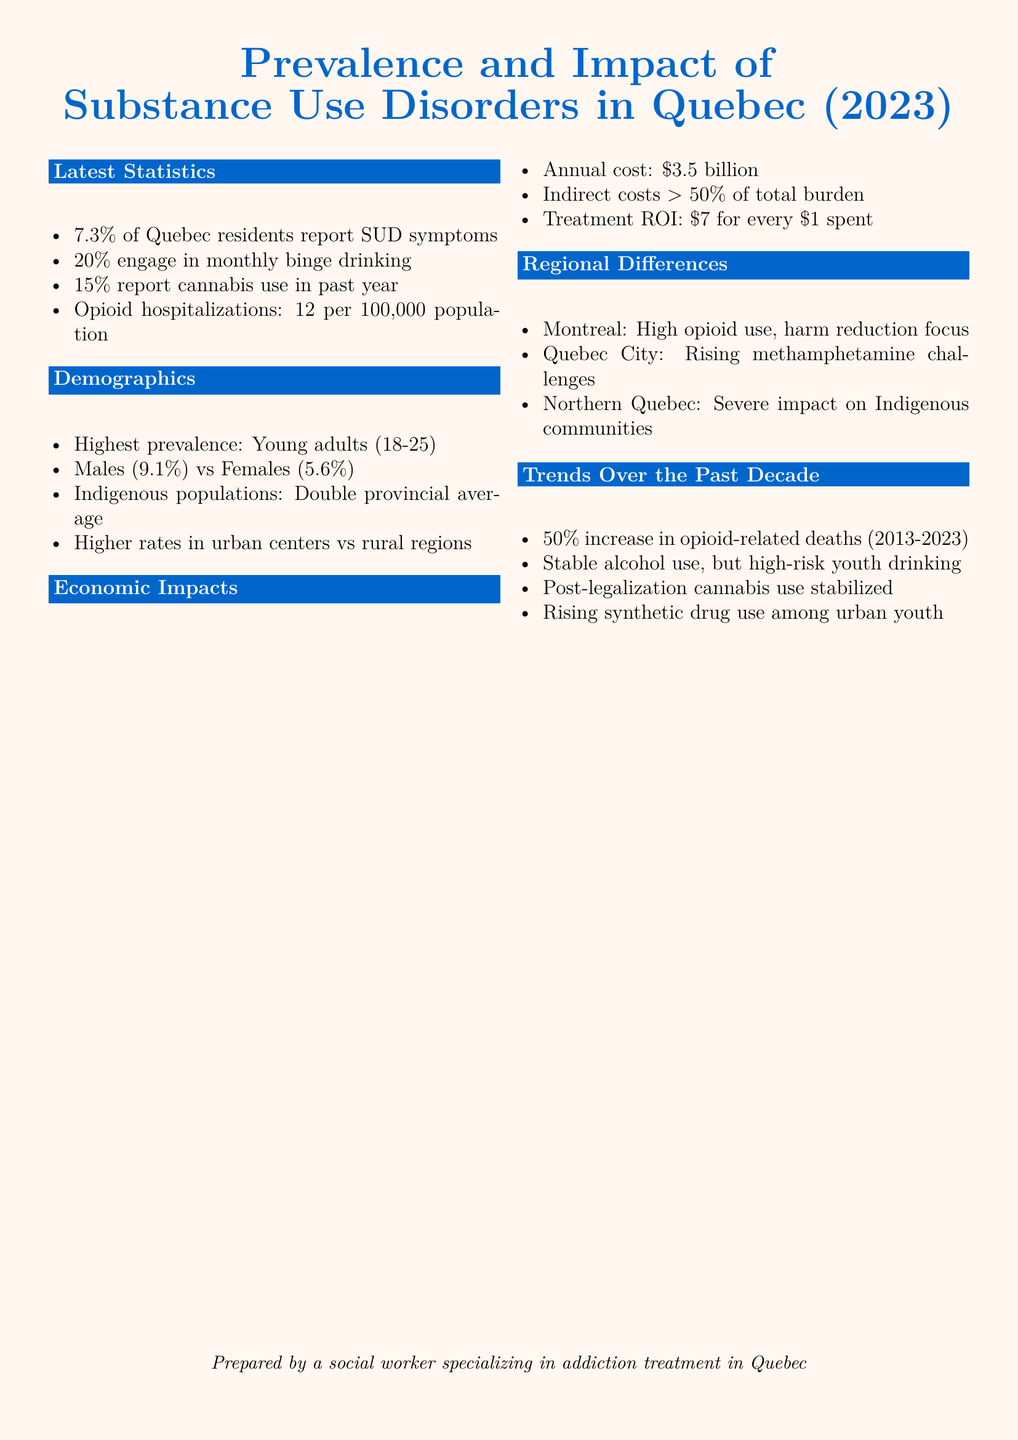What percentage of Quebec residents report SUD symptoms? The document states that 7.3% of Quebec residents report SUD symptoms.
Answer: 7.3% What is the annual cost of substance use disorders in Quebec? The document mentions that the annual cost of substance use disorders is \$3.5 billion.
Answer: \$3.5 billion Which demographic has the highest prevalence of substance use disorders? The document highlights that young adults (18-25) have the highest prevalence of substance use disorders.
Answer: Young adults (18-25) What is the rate of opioid hospitalizations per 100,000 population? The document states that the rate of opioid hospitalizations is 12 per 100,000 population.
Answer: 12 per 100,000 population What is the treatment return on investment noted in the document? The document indicates that the treatment ROI is \$7 for every \$1 spent.
Answer: \$7 for every \$1 spent What has been the trend in opioid-related deaths from 2013 to 2023? The document informs that there has been a 50% increase in opioid-related deaths during this period.
Answer: 50% increase What specific challenge is noted in Quebec City? The document specifies that Quebec City is facing rising methamphetamine challenges.
Answer: Rising methamphetamine challenges How do substance use disorder rates compare between males and females? The document states that males have a 9.1% rate while females have a 5.6% rate for substance use disorders.
Answer: Males: 9.1%, Females: 5.6% What region in Quebec experiences a severe impact on Indigenous communities? The document mentions that Northern Quebec experiences a severe impact on Indigenous communities.
Answer: Northern Quebec 